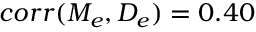Convert formula to latex. <formula><loc_0><loc_0><loc_500><loc_500>c o r r ( M _ { e } , D _ { e } ) = 0 . 4 0</formula> 